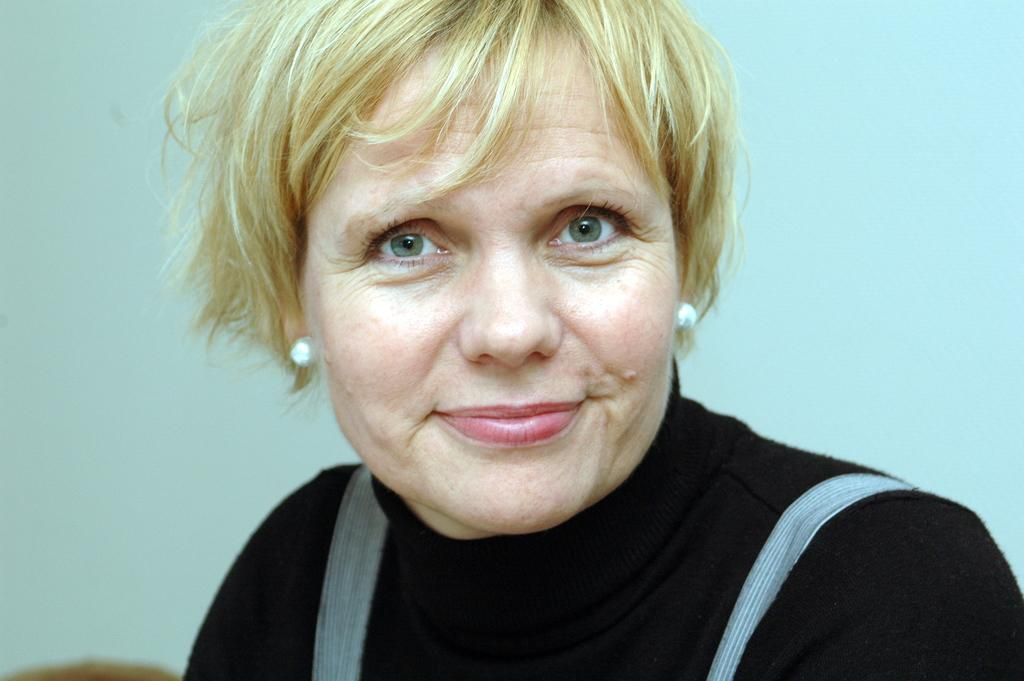Who is present in the image? There is a woman in the image. What is the woman doing in the image? The woman is smiling in the image. What is the woman wearing in the image? The woman is wearing a black dress in the image. What can be seen in the background of the image? There is a white wall in the background of the image. What color is the balloon that the woman is holding in the image? There is no balloon present in the image. How many faces can be seen on the woman's dress in the image? The woman's dress is black, and there are no faces depicted on it. 